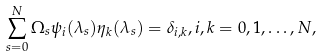Convert formula to latex. <formula><loc_0><loc_0><loc_500><loc_500>\sum _ { s = 0 } ^ { N } \Omega _ { s } \psi _ { i } ( \lambda _ { s } ) \eta _ { k } ( \lambda _ { s } ) = \delta _ { i , k } , i , k = 0 , 1 , \dots , N ,</formula> 